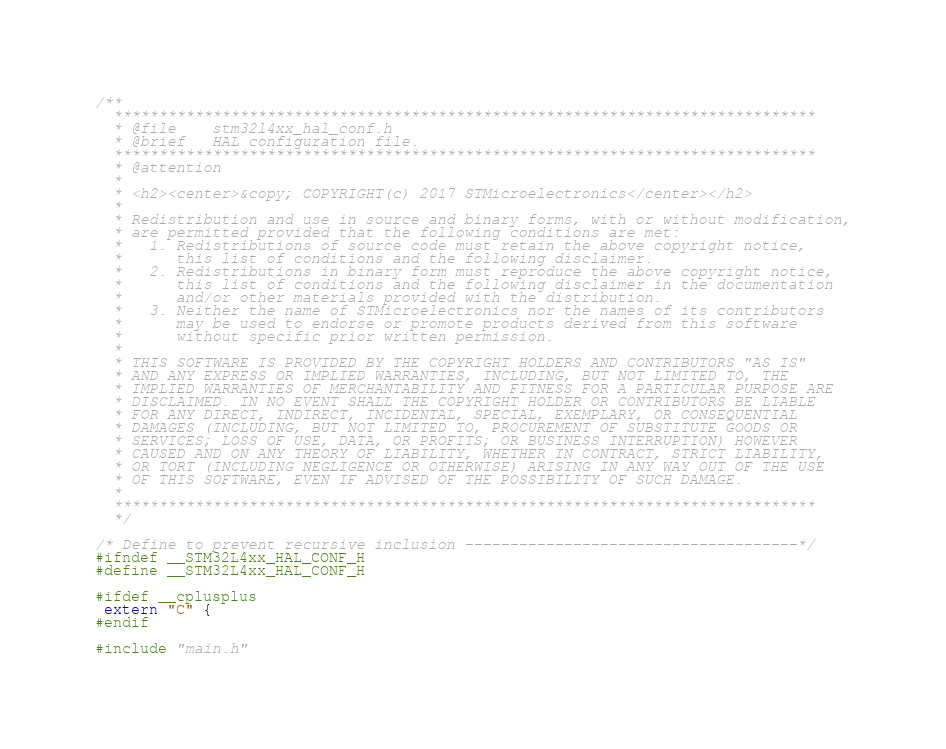<code> <loc_0><loc_0><loc_500><loc_500><_C_>/**
  ******************************************************************************
  * @file    stm32l4xx_hal_conf.h
  * @brief   HAL configuration file.             
  ******************************************************************************
  * @attention
  *
  * <h2><center>&copy; COPYRIGHT(c) 2017 STMicroelectronics</center></h2>
  *
  * Redistribution and use in source and binary forms, with or without modification,
  * are permitted provided that the following conditions are met:
  *   1. Redistributions of source code must retain the above copyright notice,
  *      this list of conditions and the following disclaimer.
  *   2. Redistributions in binary form must reproduce the above copyright notice,
  *      this list of conditions and the following disclaimer in the documentation
  *      and/or other materials provided with the distribution.
  *   3. Neither the name of STMicroelectronics nor the names of its contributors
  *      may be used to endorse or promote products derived from this software
  *      without specific prior written permission.
  *
  * THIS SOFTWARE IS PROVIDED BY THE COPYRIGHT HOLDERS AND CONTRIBUTORS "AS IS"
  * AND ANY EXPRESS OR IMPLIED WARRANTIES, INCLUDING, BUT NOT LIMITED TO, THE
  * IMPLIED WARRANTIES OF MERCHANTABILITY AND FITNESS FOR A PARTICULAR PURPOSE ARE
  * DISCLAIMED. IN NO EVENT SHALL THE COPYRIGHT HOLDER OR CONTRIBUTORS BE LIABLE
  * FOR ANY DIRECT, INDIRECT, INCIDENTAL, SPECIAL, EXEMPLARY, OR CONSEQUENTIAL
  * DAMAGES (INCLUDING, BUT NOT LIMITED TO, PROCUREMENT OF SUBSTITUTE GOODS OR
  * SERVICES; LOSS OF USE, DATA, OR PROFITS; OR BUSINESS INTERRUPTION) HOWEVER
  * CAUSED AND ON ANY THEORY OF LIABILITY, WHETHER IN CONTRACT, STRICT LIABILITY,
  * OR TORT (INCLUDING NEGLIGENCE OR OTHERWISE) ARISING IN ANY WAY OUT OF THE USE
  * OF THIS SOFTWARE, EVEN IF ADVISED OF THE POSSIBILITY OF SUCH DAMAGE.
  *
  ******************************************************************************
  */ 

/* Define to prevent recursive inclusion -------------------------------------*/
#ifndef __STM32L4xx_HAL_CONF_H
#define __STM32L4xx_HAL_CONF_H

#ifdef __cplusplus
 extern "C" {
#endif

#include "main.h" </code> 